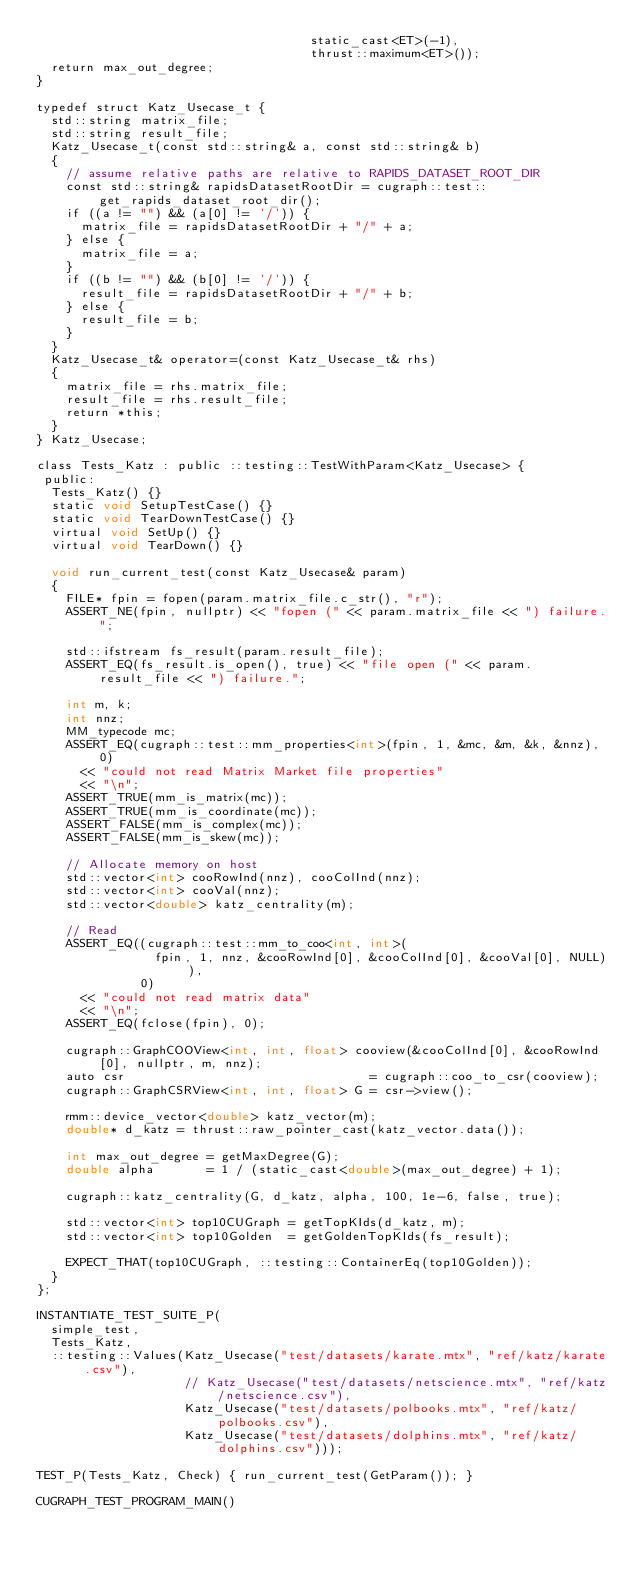Convert code to text. <code><loc_0><loc_0><loc_500><loc_500><_Cuda_>                                     static_cast<ET>(-1),
                                     thrust::maximum<ET>());
  return max_out_degree;
}

typedef struct Katz_Usecase_t {
  std::string matrix_file;
  std::string result_file;
  Katz_Usecase_t(const std::string& a, const std::string& b)
  {
    // assume relative paths are relative to RAPIDS_DATASET_ROOT_DIR
    const std::string& rapidsDatasetRootDir = cugraph::test::get_rapids_dataset_root_dir();
    if ((a != "") && (a[0] != '/')) {
      matrix_file = rapidsDatasetRootDir + "/" + a;
    } else {
      matrix_file = a;
    }
    if ((b != "") && (b[0] != '/')) {
      result_file = rapidsDatasetRootDir + "/" + b;
    } else {
      result_file = b;
    }
  }
  Katz_Usecase_t& operator=(const Katz_Usecase_t& rhs)
  {
    matrix_file = rhs.matrix_file;
    result_file = rhs.result_file;
    return *this;
  }
} Katz_Usecase;

class Tests_Katz : public ::testing::TestWithParam<Katz_Usecase> {
 public:
  Tests_Katz() {}
  static void SetupTestCase() {}
  static void TearDownTestCase() {}
  virtual void SetUp() {}
  virtual void TearDown() {}

  void run_current_test(const Katz_Usecase& param)
  {
    FILE* fpin = fopen(param.matrix_file.c_str(), "r");
    ASSERT_NE(fpin, nullptr) << "fopen (" << param.matrix_file << ") failure.";

    std::ifstream fs_result(param.result_file);
    ASSERT_EQ(fs_result.is_open(), true) << "file open (" << param.result_file << ") failure.";

    int m, k;
    int nnz;
    MM_typecode mc;
    ASSERT_EQ(cugraph::test::mm_properties<int>(fpin, 1, &mc, &m, &k, &nnz), 0)
      << "could not read Matrix Market file properties"
      << "\n";
    ASSERT_TRUE(mm_is_matrix(mc));
    ASSERT_TRUE(mm_is_coordinate(mc));
    ASSERT_FALSE(mm_is_complex(mc));
    ASSERT_FALSE(mm_is_skew(mc));

    // Allocate memory on host
    std::vector<int> cooRowInd(nnz), cooColInd(nnz);
    std::vector<int> cooVal(nnz);
    std::vector<double> katz_centrality(m);

    // Read
    ASSERT_EQ((cugraph::test::mm_to_coo<int, int>(
                fpin, 1, nnz, &cooRowInd[0], &cooColInd[0], &cooVal[0], NULL)),
              0)
      << "could not read matrix data"
      << "\n";
    ASSERT_EQ(fclose(fpin), 0);

    cugraph::GraphCOOView<int, int, float> cooview(&cooColInd[0], &cooRowInd[0], nullptr, m, nnz);
    auto csr                                 = cugraph::coo_to_csr(cooview);
    cugraph::GraphCSRView<int, int, float> G = csr->view();

    rmm::device_vector<double> katz_vector(m);
    double* d_katz = thrust::raw_pointer_cast(katz_vector.data());

    int max_out_degree = getMaxDegree(G);
    double alpha       = 1 / (static_cast<double>(max_out_degree) + 1);

    cugraph::katz_centrality(G, d_katz, alpha, 100, 1e-6, false, true);

    std::vector<int> top10CUGraph = getTopKIds(d_katz, m);
    std::vector<int> top10Golden  = getGoldenTopKIds(fs_result);

    EXPECT_THAT(top10CUGraph, ::testing::ContainerEq(top10Golden));
  }
};

INSTANTIATE_TEST_SUITE_P(
  simple_test,
  Tests_Katz,
  ::testing::Values(Katz_Usecase("test/datasets/karate.mtx", "ref/katz/karate.csv"),
                    // Katz_Usecase("test/datasets/netscience.mtx", "ref/katz/netscience.csv"),
                    Katz_Usecase("test/datasets/polbooks.mtx", "ref/katz/polbooks.csv"),
                    Katz_Usecase("test/datasets/dolphins.mtx", "ref/katz/dolphins.csv")));

TEST_P(Tests_Katz, Check) { run_current_test(GetParam()); }

CUGRAPH_TEST_PROGRAM_MAIN()
</code> 